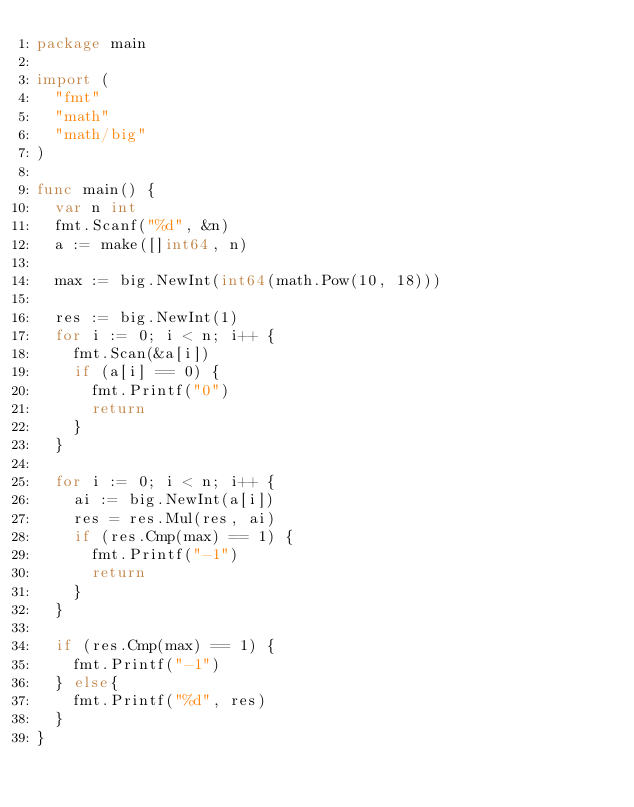<code> <loc_0><loc_0><loc_500><loc_500><_Go_>package main

import (
	"fmt"
	"math"
	"math/big"
)

func main() {
	var n int
	fmt.Scanf("%d", &n)
	a := make([]int64, n)

	max := big.NewInt(int64(math.Pow(10, 18)))

	res := big.NewInt(1)
	for i := 0; i < n; i++ {
		fmt.Scan(&a[i])
		if (a[i] == 0) {
			fmt.Printf("0")
			return
		}
	}

	for i := 0; i < n; i++ {
		ai := big.NewInt(a[i])
		res = res.Mul(res, ai)
		if (res.Cmp(max) == 1) {
			fmt.Printf("-1")
			return
		}
	}

	if (res.Cmp(max) == 1) {
		fmt.Printf("-1")
	} else{
		fmt.Printf("%d", res)
	}
}
</code> 